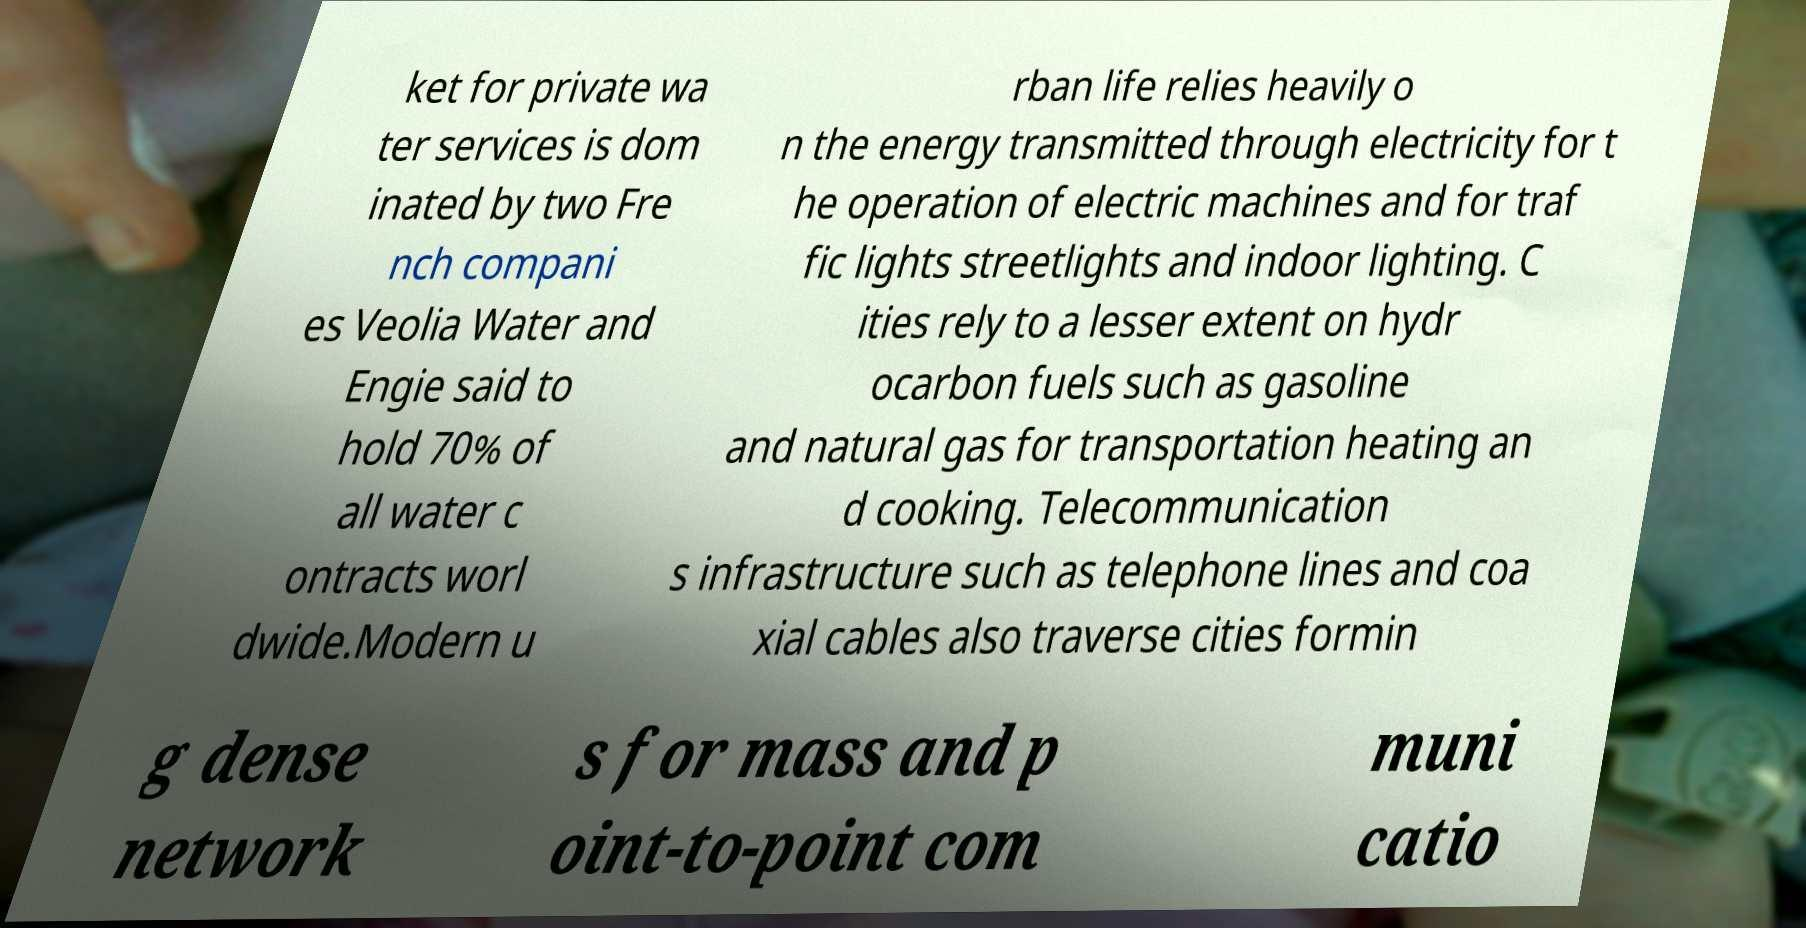Please read and relay the text visible in this image. What does it say? ket for private wa ter services is dom inated by two Fre nch compani es Veolia Water and Engie said to hold 70% of all water c ontracts worl dwide.Modern u rban life relies heavily o n the energy transmitted through electricity for t he operation of electric machines and for traf fic lights streetlights and indoor lighting. C ities rely to a lesser extent on hydr ocarbon fuels such as gasoline and natural gas for transportation heating an d cooking. Telecommunication s infrastructure such as telephone lines and coa xial cables also traverse cities formin g dense network s for mass and p oint-to-point com muni catio 